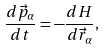Convert formula to latex. <formula><loc_0><loc_0><loc_500><loc_500>\frac { d \vec { p } _ { \alpha } } { d t } = - \frac { d H } { d \vec { r } _ { \alpha } } ,</formula> 